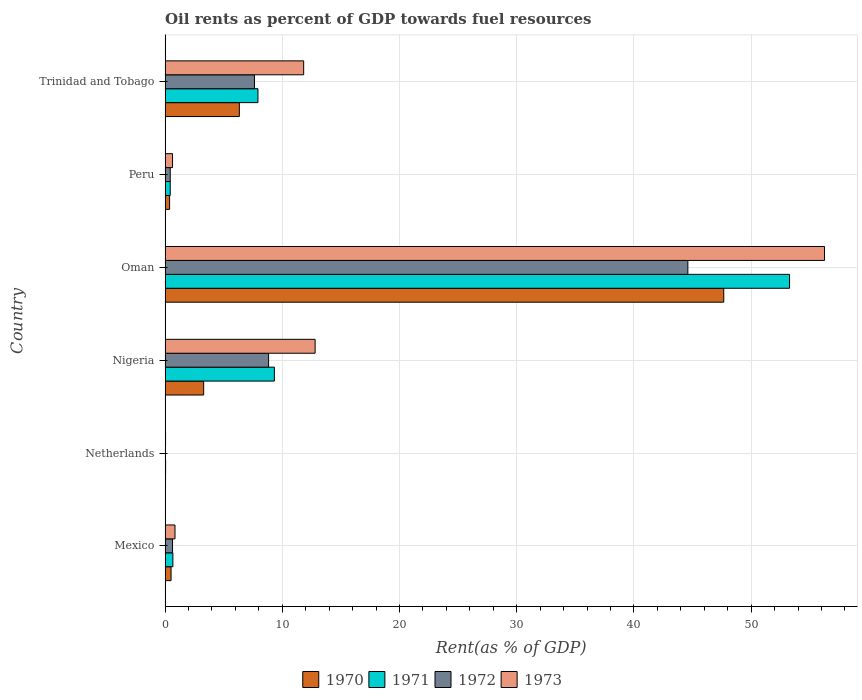How many different coloured bars are there?
Give a very brief answer. 4. Are the number of bars per tick equal to the number of legend labels?
Provide a succinct answer. Yes. Are the number of bars on each tick of the Y-axis equal?
Your response must be concise. Yes. How many bars are there on the 3rd tick from the top?
Make the answer very short. 4. How many bars are there on the 5th tick from the bottom?
Give a very brief answer. 4. What is the label of the 3rd group of bars from the top?
Your answer should be very brief. Oman. What is the oil rent in 1970 in Oman?
Offer a very short reply. 47.66. Across all countries, what is the maximum oil rent in 1971?
Provide a short and direct response. 53.28. Across all countries, what is the minimum oil rent in 1971?
Offer a terse response. 0.04. In which country was the oil rent in 1973 maximum?
Your response must be concise. Oman. In which country was the oil rent in 1970 minimum?
Your answer should be very brief. Netherlands. What is the total oil rent in 1970 in the graph?
Offer a very short reply. 58.22. What is the difference between the oil rent in 1971 in Peru and that in Trinidad and Tobago?
Keep it short and to the point. -7.49. What is the difference between the oil rent in 1971 in Mexico and the oil rent in 1970 in Trinidad and Tobago?
Make the answer very short. -5.67. What is the average oil rent in 1972 per country?
Provide a succinct answer. 10.36. What is the difference between the oil rent in 1972 and oil rent in 1970 in Netherlands?
Ensure brevity in your answer.  -0. In how many countries, is the oil rent in 1973 greater than 40 %?
Your answer should be very brief. 1. What is the ratio of the oil rent in 1971 in Mexico to that in Oman?
Provide a succinct answer. 0.01. Is the oil rent in 1971 in Nigeria less than that in Trinidad and Tobago?
Keep it short and to the point. No. What is the difference between the highest and the second highest oil rent in 1971?
Ensure brevity in your answer.  43.95. What is the difference between the highest and the lowest oil rent in 1970?
Offer a terse response. 47.62. What does the 1st bar from the top in Mexico represents?
Offer a very short reply. 1973. Is it the case that in every country, the sum of the oil rent in 1972 and oil rent in 1971 is greater than the oil rent in 1970?
Your response must be concise. Yes. How many bars are there?
Make the answer very short. 24. What is the difference between two consecutive major ticks on the X-axis?
Your response must be concise. 10. Where does the legend appear in the graph?
Make the answer very short. Bottom center. How many legend labels are there?
Provide a short and direct response. 4. What is the title of the graph?
Offer a very short reply. Oil rents as percent of GDP towards fuel resources. Does "1997" appear as one of the legend labels in the graph?
Your answer should be compact. No. What is the label or title of the X-axis?
Keep it short and to the point. Rent(as % of GDP). What is the label or title of the Y-axis?
Give a very brief answer. Country. What is the Rent(as % of GDP) of 1970 in Mexico?
Keep it short and to the point. 0.51. What is the Rent(as % of GDP) of 1971 in Mexico?
Offer a very short reply. 0.66. What is the Rent(as % of GDP) in 1972 in Mexico?
Ensure brevity in your answer.  0.63. What is the Rent(as % of GDP) in 1973 in Mexico?
Ensure brevity in your answer.  0.84. What is the Rent(as % of GDP) in 1970 in Netherlands?
Provide a succinct answer. 0.04. What is the Rent(as % of GDP) in 1971 in Netherlands?
Make the answer very short. 0.04. What is the Rent(as % of GDP) in 1972 in Netherlands?
Ensure brevity in your answer.  0.03. What is the Rent(as % of GDP) of 1973 in Netherlands?
Your answer should be very brief. 0.04. What is the Rent(as % of GDP) in 1970 in Nigeria?
Offer a very short reply. 3.29. What is the Rent(as % of GDP) of 1971 in Nigeria?
Offer a terse response. 9.32. What is the Rent(as % of GDP) of 1972 in Nigeria?
Keep it short and to the point. 8.83. What is the Rent(as % of GDP) of 1973 in Nigeria?
Give a very brief answer. 12.8. What is the Rent(as % of GDP) of 1970 in Oman?
Provide a succinct answer. 47.66. What is the Rent(as % of GDP) in 1971 in Oman?
Provide a succinct answer. 53.28. What is the Rent(as % of GDP) of 1972 in Oman?
Ensure brevity in your answer.  44.6. What is the Rent(as % of GDP) of 1973 in Oman?
Ensure brevity in your answer.  56.26. What is the Rent(as % of GDP) of 1970 in Peru?
Ensure brevity in your answer.  0.39. What is the Rent(as % of GDP) of 1971 in Peru?
Ensure brevity in your answer.  0.44. What is the Rent(as % of GDP) in 1972 in Peru?
Keep it short and to the point. 0.44. What is the Rent(as % of GDP) of 1973 in Peru?
Offer a very short reply. 0.64. What is the Rent(as % of GDP) in 1970 in Trinidad and Tobago?
Offer a terse response. 6.33. What is the Rent(as % of GDP) of 1971 in Trinidad and Tobago?
Provide a succinct answer. 7.92. What is the Rent(as % of GDP) of 1972 in Trinidad and Tobago?
Your answer should be very brief. 7.63. What is the Rent(as % of GDP) of 1973 in Trinidad and Tobago?
Your answer should be compact. 11.82. Across all countries, what is the maximum Rent(as % of GDP) of 1970?
Keep it short and to the point. 47.66. Across all countries, what is the maximum Rent(as % of GDP) in 1971?
Keep it short and to the point. 53.28. Across all countries, what is the maximum Rent(as % of GDP) in 1972?
Offer a very short reply. 44.6. Across all countries, what is the maximum Rent(as % of GDP) in 1973?
Your response must be concise. 56.26. Across all countries, what is the minimum Rent(as % of GDP) in 1970?
Ensure brevity in your answer.  0.04. Across all countries, what is the minimum Rent(as % of GDP) in 1971?
Offer a very short reply. 0.04. Across all countries, what is the minimum Rent(as % of GDP) of 1972?
Ensure brevity in your answer.  0.03. Across all countries, what is the minimum Rent(as % of GDP) in 1973?
Give a very brief answer. 0.04. What is the total Rent(as % of GDP) in 1970 in the graph?
Offer a very short reply. 58.22. What is the total Rent(as % of GDP) in 1971 in the graph?
Ensure brevity in your answer.  71.66. What is the total Rent(as % of GDP) of 1972 in the graph?
Give a very brief answer. 62.16. What is the total Rent(as % of GDP) of 1973 in the graph?
Provide a succinct answer. 82.4. What is the difference between the Rent(as % of GDP) of 1970 in Mexico and that in Netherlands?
Keep it short and to the point. 0.47. What is the difference between the Rent(as % of GDP) in 1971 in Mexico and that in Netherlands?
Provide a short and direct response. 0.62. What is the difference between the Rent(as % of GDP) of 1972 in Mexico and that in Netherlands?
Provide a short and direct response. 0.6. What is the difference between the Rent(as % of GDP) in 1973 in Mexico and that in Netherlands?
Offer a terse response. 0.81. What is the difference between the Rent(as % of GDP) in 1970 in Mexico and that in Nigeria?
Offer a very short reply. -2.78. What is the difference between the Rent(as % of GDP) of 1971 in Mexico and that in Nigeria?
Give a very brief answer. -8.66. What is the difference between the Rent(as % of GDP) of 1972 in Mexico and that in Nigeria?
Your answer should be very brief. -8.19. What is the difference between the Rent(as % of GDP) in 1973 in Mexico and that in Nigeria?
Your answer should be compact. -11.95. What is the difference between the Rent(as % of GDP) in 1970 in Mexico and that in Oman?
Keep it short and to the point. -47.15. What is the difference between the Rent(as % of GDP) of 1971 in Mexico and that in Oman?
Your response must be concise. -52.61. What is the difference between the Rent(as % of GDP) in 1972 in Mexico and that in Oman?
Provide a short and direct response. -43.97. What is the difference between the Rent(as % of GDP) of 1973 in Mexico and that in Oman?
Give a very brief answer. -55.41. What is the difference between the Rent(as % of GDP) in 1970 in Mexico and that in Peru?
Your response must be concise. 0.12. What is the difference between the Rent(as % of GDP) of 1971 in Mexico and that in Peru?
Provide a succinct answer. 0.23. What is the difference between the Rent(as % of GDP) of 1972 in Mexico and that in Peru?
Give a very brief answer. 0.2. What is the difference between the Rent(as % of GDP) of 1973 in Mexico and that in Peru?
Ensure brevity in your answer.  0.21. What is the difference between the Rent(as % of GDP) in 1970 in Mexico and that in Trinidad and Tobago?
Your answer should be very brief. -5.82. What is the difference between the Rent(as % of GDP) of 1971 in Mexico and that in Trinidad and Tobago?
Your answer should be very brief. -7.26. What is the difference between the Rent(as % of GDP) in 1972 in Mexico and that in Trinidad and Tobago?
Offer a very short reply. -6.99. What is the difference between the Rent(as % of GDP) of 1973 in Mexico and that in Trinidad and Tobago?
Offer a very short reply. -10.98. What is the difference between the Rent(as % of GDP) in 1970 in Netherlands and that in Nigeria?
Provide a short and direct response. -3.25. What is the difference between the Rent(as % of GDP) in 1971 in Netherlands and that in Nigeria?
Keep it short and to the point. -9.28. What is the difference between the Rent(as % of GDP) in 1972 in Netherlands and that in Nigeria?
Offer a very short reply. -8.79. What is the difference between the Rent(as % of GDP) in 1973 in Netherlands and that in Nigeria?
Your answer should be compact. -12.76. What is the difference between the Rent(as % of GDP) of 1970 in Netherlands and that in Oman?
Give a very brief answer. -47.62. What is the difference between the Rent(as % of GDP) in 1971 in Netherlands and that in Oman?
Offer a terse response. -53.23. What is the difference between the Rent(as % of GDP) of 1972 in Netherlands and that in Oman?
Offer a terse response. -44.57. What is the difference between the Rent(as % of GDP) in 1973 in Netherlands and that in Oman?
Provide a succinct answer. -56.22. What is the difference between the Rent(as % of GDP) in 1970 in Netherlands and that in Peru?
Offer a terse response. -0.35. What is the difference between the Rent(as % of GDP) in 1971 in Netherlands and that in Peru?
Make the answer very short. -0.39. What is the difference between the Rent(as % of GDP) of 1972 in Netherlands and that in Peru?
Ensure brevity in your answer.  -0.4. What is the difference between the Rent(as % of GDP) in 1973 in Netherlands and that in Peru?
Offer a very short reply. -0.6. What is the difference between the Rent(as % of GDP) of 1970 in Netherlands and that in Trinidad and Tobago?
Offer a very short reply. -6.3. What is the difference between the Rent(as % of GDP) in 1971 in Netherlands and that in Trinidad and Tobago?
Offer a very short reply. -7.88. What is the difference between the Rent(as % of GDP) of 1972 in Netherlands and that in Trinidad and Tobago?
Make the answer very short. -7.59. What is the difference between the Rent(as % of GDP) in 1973 in Netherlands and that in Trinidad and Tobago?
Keep it short and to the point. -11.78. What is the difference between the Rent(as % of GDP) in 1970 in Nigeria and that in Oman?
Give a very brief answer. -44.37. What is the difference between the Rent(as % of GDP) in 1971 in Nigeria and that in Oman?
Provide a succinct answer. -43.95. What is the difference between the Rent(as % of GDP) in 1972 in Nigeria and that in Oman?
Provide a succinct answer. -35.77. What is the difference between the Rent(as % of GDP) in 1973 in Nigeria and that in Oman?
Make the answer very short. -43.46. What is the difference between the Rent(as % of GDP) of 1970 in Nigeria and that in Peru?
Give a very brief answer. 2.9. What is the difference between the Rent(as % of GDP) in 1971 in Nigeria and that in Peru?
Offer a very short reply. 8.89. What is the difference between the Rent(as % of GDP) of 1972 in Nigeria and that in Peru?
Your answer should be very brief. 8.39. What is the difference between the Rent(as % of GDP) of 1973 in Nigeria and that in Peru?
Offer a very short reply. 12.16. What is the difference between the Rent(as % of GDP) in 1970 in Nigeria and that in Trinidad and Tobago?
Your answer should be very brief. -3.04. What is the difference between the Rent(as % of GDP) in 1971 in Nigeria and that in Trinidad and Tobago?
Your answer should be compact. 1.4. What is the difference between the Rent(as % of GDP) of 1972 in Nigeria and that in Trinidad and Tobago?
Give a very brief answer. 1.2. What is the difference between the Rent(as % of GDP) of 1973 in Nigeria and that in Trinidad and Tobago?
Give a very brief answer. 0.98. What is the difference between the Rent(as % of GDP) of 1970 in Oman and that in Peru?
Offer a very short reply. 47.28. What is the difference between the Rent(as % of GDP) of 1971 in Oman and that in Peru?
Make the answer very short. 52.84. What is the difference between the Rent(as % of GDP) in 1972 in Oman and that in Peru?
Your answer should be very brief. 44.16. What is the difference between the Rent(as % of GDP) of 1973 in Oman and that in Peru?
Give a very brief answer. 55.62. What is the difference between the Rent(as % of GDP) of 1970 in Oman and that in Trinidad and Tobago?
Offer a very short reply. 41.33. What is the difference between the Rent(as % of GDP) of 1971 in Oman and that in Trinidad and Tobago?
Your response must be concise. 45.35. What is the difference between the Rent(as % of GDP) of 1972 in Oman and that in Trinidad and Tobago?
Your answer should be very brief. 36.97. What is the difference between the Rent(as % of GDP) in 1973 in Oman and that in Trinidad and Tobago?
Make the answer very short. 44.44. What is the difference between the Rent(as % of GDP) of 1970 in Peru and that in Trinidad and Tobago?
Provide a short and direct response. -5.95. What is the difference between the Rent(as % of GDP) of 1971 in Peru and that in Trinidad and Tobago?
Provide a short and direct response. -7.49. What is the difference between the Rent(as % of GDP) in 1972 in Peru and that in Trinidad and Tobago?
Your answer should be very brief. -7.19. What is the difference between the Rent(as % of GDP) in 1973 in Peru and that in Trinidad and Tobago?
Offer a terse response. -11.19. What is the difference between the Rent(as % of GDP) in 1970 in Mexico and the Rent(as % of GDP) in 1971 in Netherlands?
Your response must be concise. 0.47. What is the difference between the Rent(as % of GDP) of 1970 in Mexico and the Rent(as % of GDP) of 1972 in Netherlands?
Offer a very short reply. 0.47. What is the difference between the Rent(as % of GDP) of 1970 in Mexico and the Rent(as % of GDP) of 1973 in Netherlands?
Keep it short and to the point. 0.47. What is the difference between the Rent(as % of GDP) in 1971 in Mexico and the Rent(as % of GDP) in 1972 in Netherlands?
Your answer should be very brief. 0.63. What is the difference between the Rent(as % of GDP) in 1971 in Mexico and the Rent(as % of GDP) in 1973 in Netherlands?
Your answer should be compact. 0.62. What is the difference between the Rent(as % of GDP) of 1972 in Mexico and the Rent(as % of GDP) of 1973 in Netherlands?
Your answer should be compact. 0.6. What is the difference between the Rent(as % of GDP) in 1970 in Mexico and the Rent(as % of GDP) in 1971 in Nigeria?
Make the answer very short. -8.81. What is the difference between the Rent(as % of GDP) in 1970 in Mexico and the Rent(as % of GDP) in 1972 in Nigeria?
Your answer should be compact. -8.32. What is the difference between the Rent(as % of GDP) in 1970 in Mexico and the Rent(as % of GDP) in 1973 in Nigeria?
Your response must be concise. -12.29. What is the difference between the Rent(as % of GDP) of 1971 in Mexico and the Rent(as % of GDP) of 1972 in Nigeria?
Your answer should be compact. -8.17. What is the difference between the Rent(as % of GDP) in 1971 in Mexico and the Rent(as % of GDP) in 1973 in Nigeria?
Ensure brevity in your answer.  -12.14. What is the difference between the Rent(as % of GDP) in 1972 in Mexico and the Rent(as % of GDP) in 1973 in Nigeria?
Provide a succinct answer. -12.16. What is the difference between the Rent(as % of GDP) in 1970 in Mexico and the Rent(as % of GDP) in 1971 in Oman?
Offer a terse response. -52.77. What is the difference between the Rent(as % of GDP) of 1970 in Mexico and the Rent(as % of GDP) of 1972 in Oman?
Make the answer very short. -44.09. What is the difference between the Rent(as % of GDP) of 1970 in Mexico and the Rent(as % of GDP) of 1973 in Oman?
Give a very brief answer. -55.75. What is the difference between the Rent(as % of GDP) of 1971 in Mexico and the Rent(as % of GDP) of 1972 in Oman?
Your answer should be compact. -43.94. What is the difference between the Rent(as % of GDP) in 1971 in Mexico and the Rent(as % of GDP) in 1973 in Oman?
Provide a succinct answer. -55.6. What is the difference between the Rent(as % of GDP) in 1972 in Mexico and the Rent(as % of GDP) in 1973 in Oman?
Provide a succinct answer. -55.62. What is the difference between the Rent(as % of GDP) of 1970 in Mexico and the Rent(as % of GDP) of 1971 in Peru?
Offer a very short reply. 0.07. What is the difference between the Rent(as % of GDP) in 1970 in Mexico and the Rent(as % of GDP) in 1972 in Peru?
Keep it short and to the point. 0.07. What is the difference between the Rent(as % of GDP) in 1970 in Mexico and the Rent(as % of GDP) in 1973 in Peru?
Ensure brevity in your answer.  -0.13. What is the difference between the Rent(as % of GDP) in 1971 in Mexico and the Rent(as % of GDP) in 1972 in Peru?
Your response must be concise. 0.22. What is the difference between the Rent(as % of GDP) in 1971 in Mexico and the Rent(as % of GDP) in 1973 in Peru?
Make the answer very short. 0.03. What is the difference between the Rent(as % of GDP) in 1972 in Mexico and the Rent(as % of GDP) in 1973 in Peru?
Provide a short and direct response. -0. What is the difference between the Rent(as % of GDP) in 1970 in Mexico and the Rent(as % of GDP) in 1971 in Trinidad and Tobago?
Your response must be concise. -7.41. What is the difference between the Rent(as % of GDP) in 1970 in Mexico and the Rent(as % of GDP) in 1972 in Trinidad and Tobago?
Your response must be concise. -7.12. What is the difference between the Rent(as % of GDP) in 1970 in Mexico and the Rent(as % of GDP) in 1973 in Trinidad and Tobago?
Make the answer very short. -11.31. What is the difference between the Rent(as % of GDP) in 1971 in Mexico and the Rent(as % of GDP) in 1972 in Trinidad and Tobago?
Provide a succinct answer. -6.96. What is the difference between the Rent(as % of GDP) of 1971 in Mexico and the Rent(as % of GDP) of 1973 in Trinidad and Tobago?
Provide a succinct answer. -11.16. What is the difference between the Rent(as % of GDP) of 1972 in Mexico and the Rent(as % of GDP) of 1973 in Trinidad and Tobago?
Your answer should be very brief. -11.19. What is the difference between the Rent(as % of GDP) of 1970 in Netherlands and the Rent(as % of GDP) of 1971 in Nigeria?
Your answer should be compact. -9.29. What is the difference between the Rent(as % of GDP) of 1970 in Netherlands and the Rent(as % of GDP) of 1972 in Nigeria?
Provide a short and direct response. -8.79. What is the difference between the Rent(as % of GDP) in 1970 in Netherlands and the Rent(as % of GDP) in 1973 in Nigeria?
Give a very brief answer. -12.76. What is the difference between the Rent(as % of GDP) of 1971 in Netherlands and the Rent(as % of GDP) of 1972 in Nigeria?
Keep it short and to the point. -8.79. What is the difference between the Rent(as % of GDP) of 1971 in Netherlands and the Rent(as % of GDP) of 1973 in Nigeria?
Give a very brief answer. -12.76. What is the difference between the Rent(as % of GDP) in 1972 in Netherlands and the Rent(as % of GDP) in 1973 in Nigeria?
Offer a very short reply. -12.76. What is the difference between the Rent(as % of GDP) in 1970 in Netherlands and the Rent(as % of GDP) in 1971 in Oman?
Your answer should be compact. -53.24. What is the difference between the Rent(as % of GDP) of 1970 in Netherlands and the Rent(as % of GDP) of 1972 in Oman?
Give a very brief answer. -44.56. What is the difference between the Rent(as % of GDP) in 1970 in Netherlands and the Rent(as % of GDP) in 1973 in Oman?
Keep it short and to the point. -56.22. What is the difference between the Rent(as % of GDP) of 1971 in Netherlands and the Rent(as % of GDP) of 1972 in Oman?
Your answer should be compact. -44.56. What is the difference between the Rent(as % of GDP) in 1971 in Netherlands and the Rent(as % of GDP) in 1973 in Oman?
Offer a very short reply. -56.22. What is the difference between the Rent(as % of GDP) of 1972 in Netherlands and the Rent(as % of GDP) of 1973 in Oman?
Your answer should be compact. -56.22. What is the difference between the Rent(as % of GDP) of 1970 in Netherlands and the Rent(as % of GDP) of 1971 in Peru?
Give a very brief answer. -0.4. What is the difference between the Rent(as % of GDP) of 1970 in Netherlands and the Rent(as % of GDP) of 1972 in Peru?
Your response must be concise. -0.4. What is the difference between the Rent(as % of GDP) of 1970 in Netherlands and the Rent(as % of GDP) of 1973 in Peru?
Ensure brevity in your answer.  -0.6. What is the difference between the Rent(as % of GDP) in 1971 in Netherlands and the Rent(as % of GDP) in 1972 in Peru?
Keep it short and to the point. -0.4. What is the difference between the Rent(as % of GDP) of 1971 in Netherlands and the Rent(as % of GDP) of 1973 in Peru?
Your response must be concise. -0.59. What is the difference between the Rent(as % of GDP) of 1972 in Netherlands and the Rent(as % of GDP) of 1973 in Peru?
Offer a terse response. -0.6. What is the difference between the Rent(as % of GDP) in 1970 in Netherlands and the Rent(as % of GDP) in 1971 in Trinidad and Tobago?
Make the answer very short. -7.88. What is the difference between the Rent(as % of GDP) of 1970 in Netherlands and the Rent(as % of GDP) of 1972 in Trinidad and Tobago?
Offer a very short reply. -7.59. What is the difference between the Rent(as % of GDP) of 1970 in Netherlands and the Rent(as % of GDP) of 1973 in Trinidad and Tobago?
Ensure brevity in your answer.  -11.79. What is the difference between the Rent(as % of GDP) of 1971 in Netherlands and the Rent(as % of GDP) of 1972 in Trinidad and Tobago?
Your response must be concise. -7.58. What is the difference between the Rent(as % of GDP) of 1971 in Netherlands and the Rent(as % of GDP) of 1973 in Trinidad and Tobago?
Offer a very short reply. -11.78. What is the difference between the Rent(as % of GDP) in 1972 in Netherlands and the Rent(as % of GDP) in 1973 in Trinidad and Tobago?
Offer a very short reply. -11.79. What is the difference between the Rent(as % of GDP) of 1970 in Nigeria and the Rent(as % of GDP) of 1971 in Oman?
Provide a succinct answer. -49.99. What is the difference between the Rent(as % of GDP) of 1970 in Nigeria and the Rent(as % of GDP) of 1972 in Oman?
Make the answer very short. -41.31. What is the difference between the Rent(as % of GDP) of 1970 in Nigeria and the Rent(as % of GDP) of 1973 in Oman?
Your answer should be compact. -52.97. What is the difference between the Rent(as % of GDP) in 1971 in Nigeria and the Rent(as % of GDP) in 1972 in Oman?
Provide a succinct answer. -35.28. What is the difference between the Rent(as % of GDP) in 1971 in Nigeria and the Rent(as % of GDP) in 1973 in Oman?
Make the answer very short. -46.94. What is the difference between the Rent(as % of GDP) of 1972 in Nigeria and the Rent(as % of GDP) of 1973 in Oman?
Provide a succinct answer. -47.43. What is the difference between the Rent(as % of GDP) in 1970 in Nigeria and the Rent(as % of GDP) in 1971 in Peru?
Provide a short and direct response. 2.85. What is the difference between the Rent(as % of GDP) in 1970 in Nigeria and the Rent(as % of GDP) in 1972 in Peru?
Provide a short and direct response. 2.85. What is the difference between the Rent(as % of GDP) in 1970 in Nigeria and the Rent(as % of GDP) in 1973 in Peru?
Offer a very short reply. 2.65. What is the difference between the Rent(as % of GDP) in 1971 in Nigeria and the Rent(as % of GDP) in 1972 in Peru?
Keep it short and to the point. 8.88. What is the difference between the Rent(as % of GDP) in 1971 in Nigeria and the Rent(as % of GDP) in 1973 in Peru?
Ensure brevity in your answer.  8.69. What is the difference between the Rent(as % of GDP) in 1972 in Nigeria and the Rent(as % of GDP) in 1973 in Peru?
Give a very brief answer. 8.19. What is the difference between the Rent(as % of GDP) in 1970 in Nigeria and the Rent(as % of GDP) in 1971 in Trinidad and Tobago?
Your response must be concise. -4.63. What is the difference between the Rent(as % of GDP) of 1970 in Nigeria and the Rent(as % of GDP) of 1972 in Trinidad and Tobago?
Offer a terse response. -4.34. What is the difference between the Rent(as % of GDP) of 1970 in Nigeria and the Rent(as % of GDP) of 1973 in Trinidad and Tobago?
Ensure brevity in your answer.  -8.53. What is the difference between the Rent(as % of GDP) of 1971 in Nigeria and the Rent(as % of GDP) of 1972 in Trinidad and Tobago?
Offer a very short reply. 1.7. What is the difference between the Rent(as % of GDP) of 1972 in Nigeria and the Rent(as % of GDP) of 1973 in Trinidad and Tobago?
Provide a short and direct response. -2.99. What is the difference between the Rent(as % of GDP) in 1970 in Oman and the Rent(as % of GDP) in 1971 in Peru?
Provide a succinct answer. 47.23. What is the difference between the Rent(as % of GDP) in 1970 in Oman and the Rent(as % of GDP) in 1972 in Peru?
Provide a succinct answer. 47.22. What is the difference between the Rent(as % of GDP) in 1970 in Oman and the Rent(as % of GDP) in 1973 in Peru?
Your answer should be compact. 47.03. What is the difference between the Rent(as % of GDP) in 1971 in Oman and the Rent(as % of GDP) in 1972 in Peru?
Provide a short and direct response. 52.84. What is the difference between the Rent(as % of GDP) of 1971 in Oman and the Rent(as % of GDP) of 1973 in Peru?
Your answer should be very brief. 52.64. What is the difference between the Rent(as % of GDP) of 1972 in Oman and the Rent(as % of GDP) of 1973 in Peru?
Provide a short and direct response. 43.96. What is the difference between the Rent(as % of GDP) of 1970 in Oman and the Rent(as % of GDP) of 1971 in Trinidad and Tobago?
Ensure brevity in your answer.  39.74. What is the difference between the Rent(as % of GDP) in 1970 in Oman and the Rent(as % of GDP) in 1972 in Trinidad and Tobago?
Make the answer very short. 40.04. What is the difference between the Rent(as % of GDP) in 1970 in Oman and the Rent(as % of GDP) in 1973 in Trinidad and Tobago?
Ensure brevity in your answer.  35.84. What is the difference between the Rent(as % of GDP) in 1971 in Oman and the Rent(as % of GDP) in 1972 in Trinidad and Tobago?
Offer a very short reply. 45.65. What is the difference between the Rent(as % of GDP) in 1971 in Oman and the Rent(as % of GDP) in 1973 in Trinidad and Tobago?
Offer a very short reply. 41.45. What is the difference between the Rent(as % of GDP) in 1972 in Oman and the Rent(as % of GDP) in 1973 in Trinidad and Tobago?
Your answer should be compact. 32.78. What is the difference between the Rent(as % of GDP) in 1970 in Peru and the Rent(as % of GDP) in 1971 in Trinidad and Tobago?
Give a very brief answer. -7.54. What is the difference between the Rent(as % of GDP) of 1970 in Peru and the Rent(as % of GDP) of 1972 in Trinidad and Tobago?
Provide a short and direct response. -7.24. What is the difference between the Rent(as % of GDP) in 1970 in Peru and the Rent(as % of GDP) in 1973 in Trinidad and Tobago?
Offer a terse response. -11.44. What is the difference between the Rent(as % of GDP) of 1971 in Peru and the Rent(as % of GDP) of 1972 in Trinidad and Tobago?
Keep it short and to the point. -7.19. What is the difference between the Rent(as % of GDP) in 1971 in Peru and the Rent(as % of GDP) in 1973 in Trinidad and Tobago?
Your answer should be compact. -11.39. What is the difference between the Rent(as % of GDP) of 1972 in Peru and the Rent(as % of GDP) of 1973 in Trinidad and Tobago?
Offer a very short reply. -11.38. What is the average Rent(as % of GDP) in 1970 per country?
Provide a short and direct response. 9.7. What is the average Rent(as % of GDP) in 1971 per country?
Provide a short and direct response. 11.94. What is the average Rent(as % of GDP) of 1972 per country?
Keep it short and to the point. 10.36. What is the average Rent(as % of GDP) in 1973 per country?
Keep it short and to the point. 13.73. What is the difference between the Rent(as % of GDP) in 1970 and Rent(as % of GDP) in 1971 in Mexico?
Provide a succinct answer. -0.15. What is the difference between the Rent(as % of GDP) of 1970 and Rent(as % of GDP) of 1972 in Mexico?
Provide a succinct answer. -0.13. What is the difference between the Rent(as % of GDP) in 1970 and Rent(as % of GDP) in 1973 in Mexico?
Provide a succinct answer. -0.34. What is the difference between the Rent(as % of GDP) of 1971 and Rent(as % of GDP) of 1972 in Mexico?
Keep it short and to the point. 0.03. What is the difference between the Rent(as % of GDP) of 1971 and Rent(as % of GDP) of 1973 in Mexico?
Ensure brevity in your answer.  -0.18. What is the difference between the Rent(as % of GDP) in 1972 and Rent(as % of GDP) in 1973 in Mexico?
Offer a terse response. -0.21. What is the difference between the Rent(as % of GDP) of 1970 and Rent(as % of GDP) of 1971 in Netherlands?
Your answer should be compact. -0.01. What is the difference between the Rent(as % of GDP) in 1970 and Rent(as % of GDP) in 1972 in Netherlands?
Your answer should be compact. 0. What is the difference between the Rent(as % of GDP) in 1970 and Rent(as % of GDP) in 1973 in Netherlands?
Your answer should be compact. -0. What is the difference between the Rent(as % of GDP) of 1971 and Rent(as % of GDP) of 1972 in Netherlands?
Your answer should be compact. 0.01. What is the difference between the Rent(as % of GDP) of 1971 and Rent(as % of GDP) of 1973 in Netherlands?
Provide a short and direct response. 0. What is the difference between the Rent(as % of GDP) of 1972 and Rent(as % of GDP) of 1973 in Netherlands?
Give a very brief answer. -0. What is the difference between the Rent(as % of GDP) of 1970 and Rent(as % of GDP) of 1971 in Nigeria?
Your answer should be very brief. -6.03. What is the difference between the Rent(as % of GDP) of 1970 and Rent(as % of GDP) of 1972 in Nigeria?
Give a very brief answer. -5.54. What is the difference between the Rent(as % of GDP) in 1970 and Rent(as % of GDP) in 1973 in Nigeria?
Make the answer very short. -9.51. What is the difference between the Rent(as % of GDP) in 1971 and Rent(as % of GDP) in 1972 in Nigeria?
Your response must be concise. 0.49. What is the difference between the Rent(as % of GDP) in 1971 and Rent(as % of GDP) in 1973 in Nigeria?
Offer a terse response. -3.48. What is the difference between the Rent(as % of GDP) in 1972 and Rent(as % of GDP) in 1973 in Nigeria?
Give a very brief answer. -3.97. What is the difference between the Rent(as % of GDP) in 1970 and Rent(as % of GDP) in 1971 in Oman?
Your answer should be very brief. -5.61. What is the difference between the Rent(as % of GDP) of 1970 and Rent(as % of GDP) of 1972 in Oman?
Your response must be concise. 3.06. What is the difference between the Rent(as % of GDP) of 1970 and Rent(as % of GDP) of 1973 in Oman?
Provide a succinct answer. -8.6. What is the difference between the Rent(as % of GDP) of 1971 and Rent(as % of GDP) of 1972 in Oman?
Keep it short and to the point. 8.68. What is the difference between the Rent(as % of GDP) of 1971 and Rent(as % of GDP) of 1973 in Oman?
Offer a very short reply. -2.98. What is the difference between the Rent(as % of GDP) of 1972 and Rent(as % of GDP) of 1973 in Oman?
Your answer should be very brief. -11.66. What is the difference between the Rent(as % of GDP) of 1970 and Rent(as % of GDP) of 1971 in Peru?
Your answer should be very brief. -0.05. What is the difference between the Rent(as % of GDP) in 1970 and Rent(as % of GDP) in 1972 in Peru?
Your answer should be very brief. -0.05. What is the difference between the Rent(as % of GDP) in 1970 and Rent(as % of GDP) in 1973 in Peru?
Offer a terse response. -0.25. What is the difference between the Rent(as % of GDP) in 1971 and Rent(as % of GDP) in 1972 in Peru?
Make the answer very short. -0. What is the difference between the Rent(as % of GDP) of 1971 and Rent(as % of GDP) of 1973 in Peru?
Your answer should be very brief. -0.2. What is the difference between the Rent(as % of GDP) in 1972 and Rent(as % of GDP) in 1973 in Peru?
Provide a short and direct response. -0.2. What is the difference between the Rent(as % of GDP) of 1970 and Rent(as % of GDP) of 1971 in Trinidad and Tobago?
Ensure brevity in your answer.  -1.59. What is the difference between the Rent(as % of GDP) of 1970 and Rent(as % of GDP) of 1972 in Trinidad and Tobago?
Offer a very short reply. -1.29. What is the difference between the Rent(as % of GDP) of 1970 and Rent(as % of GDP) of 1973 in Trinidad and Tobago?
Offer a terse response. -5.49. What is the difference between the Rent(as % of GDP) of 1971 and Rent(as % of GDP) of 1972 in Trinidad and Tobago?
Offer a very short reply. 0.3. What is the difference between the Rent(as % of GDP) of 1971 and Rent(as % of GDP) of 1973 in Trinidad and Tobago?
Make the answer very short. -3.9. What is the difference between the Rent(as % of GDP) in 1972 and Rent(as % of GDP) in 1973 in Trinidad and Tobago?
Give a very brief answer. -4.2. What is the ratio of the Rent(as % of GDP) of 1970 in Mexico to that in Netherlands?
Provide a short and direct response. 13.43. What is the ratio of the Rent(as % of GDP) of 1971 in Mexico to that in Netherlands?
Your answer should be compact. 15.37. What is the ratio of the Rent(as % of GDP) of 1972 in Mexico to that in Netherlands?
Offer a terse response. 18.28. What is the ratio of the Rent(as % of GDP) of 1973 in Mexico to that in Netherlands?
Your response must be concise. 21.38. What is the ratio of the Rent(as % of GDP) of 1970 in Mexico to that in Nigeria?
Your answer should be very brief. 0.15. What is the ratio of the Rent(as % of GDP) in 1971 in Mexico to that in Nigeria?
Provide a short and direct response. 0.07. What is the ratio of the Rent(as % of GDP) in 1972 in Mexico to that in Nigeria?
Your answer should be compact. 0.07. What is the ratio of the Rent(as % of GDP) of 1973 in Mexico to that in Nigeria?
Make the answer very short. 0.07. What is the ratio of the Rent(as % of GDP) in 1970 in Mexico to that in Oman?
Offer a very short reply. 0.01. What is the ratio of the Rent(as % of GDP) in 1971 in Mexico to that in Oman?
Make the answer very short. 0.01. What is the ratio of the Rent(as % of GDP) of 1972 in Mexico to that in Oman?
Keep it short and to the point. 0.01. What is the ratio of the Rent(as % of GDP) in 1973 in Mexico to that in Oman?
Provide a succinct answer. 0.01. What is the ratio of the Rent(as % of GDP) of 1970 in Mexico to that in Peru?
Your answer should be very brief. 1.32. What is the ratio of the Rent(as % of GDP) in 1971 in Mexico to that in Peru?
Give a very brief answer. 1.52. What is the ratio of the Rent(as % of GDP) of 1972 in Mexico to that in Peru?
Your response must be concise. 1.45. What is the ratio of the Rent(as % of GDP) in 1973 in Mexico to that in Peru?
Give a very brief answer. 1.33. What is the ratio of the Rent(as % of GDP) of 1970 in Mexico to that in Trinidad and Tobago?
Make the answer very short. 0.08. What is the ratio of the Rent(as % of GDP) in 1971 in Mexico to that in Trinidad and Tobago?
Provide a short and direct response. 0.08. What is the ratio of the Rent(as % of GDP) of 1972 in Mexico to that in Trinidad and Tobago?
Make the answer very short. 0.08. What is the ratio of the Rent(as % of GDP) of 1973 in Mexico to that in Trinidad and Tobago?
Your answer should be compact. 0.07. What is the ratio of the Rent(as % of GDP) in 1970 in Netherlands to that in Nigeria?
Your response must be concise. 0.01. What is the ratio of the Rent(as % of GDP) of 1971 in Netherlands to that in Nigeria?
Make the answer very short. 0. What is the ratio of the Rent(as % of GDP) of 1972 in Netherlands to that in Nigeria?
Offer a very short reply. 0. What is the ratio of the Rent(as % of GDP) in 1973 in Netherlands to that in Nigeria?
Your answer should be very brief. 0. What is the ratio of the Rent(as % of GDP) of 1970 in Netherlands to that in Oman?
Offer a terse response. 0. What is the ratio of the Rent(as % of GDP) of 1971 in Netherlands to that in Oman?
Provide a short and direct response. 0. What is the ratio of the Rent(as % of GDP) of 1972 in Netherlands to that in Oman?
Ensure brevity in your answer.  0. What is the ratio of the Rent(as % of GDP) in 1973 in Netherlands to that in Oman?
Give a very brief answer. 0. What is the ratio of the Rent(as % of GDP) in 1970 in Netherlands to that in Peru?
Your answer should be compact. 0.1. What is the ratio of the Rent(as % of GDP) of 1971 in Netherlands to that in Peru?
Make the answer very short. 0.1. What is the ratio of the Rent(as % of GDP) of 1972 in Netherlands to that in Peru?
Offer a very short reply. 0.08. What is the ratio of the Rent(as % of GDP) in 1973 in Netherlands to that in Peru?
Your answer should be very brief. 0.06. What is the ratio of the Rent(as % of GDP) in 1970 in Netherlands to that in Trinidad and Tobago?
Offer a very short reply. 0.01. What is the ratio of the Rent(as % of GDP) of 1971 in Netherlands to that in Trinidad and Tobago?
Keep it short and to the point. 0.01. What is the ratio of the Rent(as % of GDP) in 1972 in Netherlands to that in Trinidad and Tobago?
Provide a succinct answer. 0. What is the ratio of the Rent(as % of GDP) of 1973 in Netherlands to that in Trinidad and Tobago?
Your response must be concise. 0. What is the ratio of the Rent(as % of GDP) in 1970 in Nigeria to that in Oman?
Provide a short and direct response. 0.07. What is the ratio of the Rent(as % of GDP) of 1971 in Nigeria to that in Oman?
Give a very brief answer. 0.17. What is the ratio of the Rent(as % of GDP) in 1972 in Nigeria to that in Oman?
Ensure brevity in your answer.  0.2. What is the ratio of the Rent(as % of GDP) of 1973 in Nigeria to that in Oman?
Your answer should be compact. 0.23. What is the ratio of the Rent(as % of GDP) of 1970 in Nigeria to that in Peru?
Offer a very short reply. 8.53. What is the ratio of the Rent(as % of GDP) in 1971 in Nigeria to that in Peru?
Provide a succinct answer. 21.35. What is the ratio of the Rent(as % of GDP) of 1972 in Nigeria to that in Peru?
Ensure brevity in your answer.  20.12. What is the ratio of the Rent(as % of GDP) in 1973 in Nigeria to that in Peru?
Ensure brevity in your answer.  20.13. What is the ratio of the Rent(as % of GDP) of 1970 in Nigeria to that in Trinidad and Tobago?
Keep it short and to the point. 0.52. What is the ratio of the Rent(as % of GDP) of 1971 in Nigeria to that in Trinidad and Tobago?
Provide a succinct answer. 1.18. What is the ratio of the Rent(as % of GDP) of 1972 in Nigeria to that in Trinidad and Tobago?
Your response must be concise. 1.16. What is the ratio of the Rent(as % of GDP) of 1973 in Nigeria to that in Trinidad and Tobago?
Provide a succinct answer. 1.08. What is the ratio of the Rent(as % of GDP) in 1970 in Oman to that in Peru?
Ensure brevity in your answer.  123.65. What is the ratio of the Rent(as % of GDP) of 1971 in Oman to that in Peru?
Make the answer very short. 121.98. What is the ratio of the Rent(as % of GDP) in 1972 in Oman to that in Peru?
Ensure brevity in your answer.  101.64. What is the ratio of the Rent(as % of GDP) of 1973 in Oman to that in Peru?
Make the answer very short. 88.49. What is the ratio of the Rent(as % of GDP) in 1970 in Oman to that in Trinidad and Tobago?
Provide a short and direct response. 7.52. What is the ratio of the Rent(as % of GDP) in 1971 in Oman to that in Trinidad and Tobago?
Provide a short and direct response. 6.73. What is the ratio of the Rent(as % of GDP) in 1972 in Oman to that in Trinidad and Tobago?
Make the answer very short. 5.85. What is the ratio of the Rent(as % of GDP) of 1973 in Oman to that in Trinidad and Tobago?
Your response must be concise. 4.76. What is the ratio of the Rent(as % of GDP) in 1970 in Peru to that in Trinidad and Tobago?
Keep it short and to the point. 0.06. What is the ratio of the Rent(as % of GDP) in 1971 in Peru to that in Trinidad and Tobago?
Provide a short and direct response. 0.06. What is the ratio of the Rent(as % of GDP) of 1972 in Peru to that in Trinidad and Tobago?
Your answer should be very brief. 0.06. What is the ratio of the Rent(as % of GDP) in 1973 in Peru to that in Trinidad and Tobago?
Your response must be concise. 0.05. What is the difference between the highest and the second highest Rent(as % of GDP) in 1970?
Your answer should be compact. 41.33. What is the difference between the highest and the second highest Rent(as % of GDP) of 1971?
Give a very brief answer. 43.95. What is the difference between the highest and the second highest Rent(as % of GDP) of 1972?
Keep it short and to the point. 35.77. What is the difference between the highest and the second highest Rent(as % of GDP) of 1973?
Give a very brief answer. 43.46. What is the difference between the highest and the lowest Rent(as % of GDP) of 1970?
Provide a short and direct response. 47.62. What is the difference between the highest and the lowest Rent(as % of GDP) of 1971?
Make the answer very short. 53.23. What is the difference between the highest and the lowest Rent(as % of GDP) in 1972?
Your response must be concise. 44.57. What is the difference between the highest and the lowest Rent(as % of GDP) in 1973?
Keep it short and to the point. 56.22. 